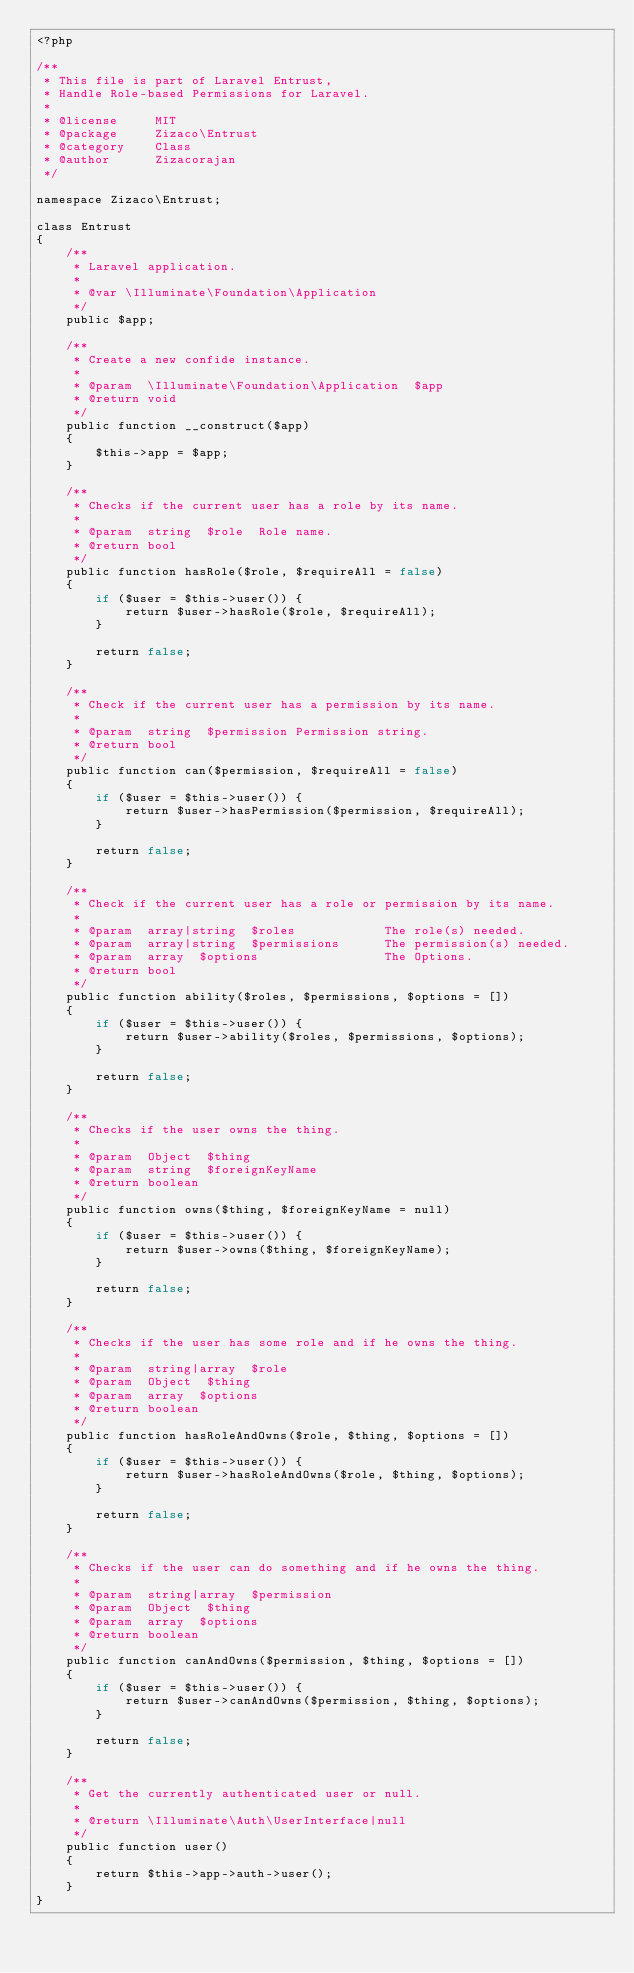<code> <loc_0><loc_0><loc_500><loc_500><_PHP_><?php

/**
 * This file is part of Laravel Entrust,
 * Handle Role-based Permissions for Laravel.
 *
 * @license     MIT
 * @package     Zizaco\Entrust
 * @category    Class
 * @author      Zizacorajan
 */

namespace Zizaco\Entrust;

class Entrust
{
    /**
     * Laravel application.
     *
     * @var \Illuminate\Foundation\Application
     */
    public $app;

    /**
     * Create a new confide instance.
     *
     * @param  \Illuminate\Foundation\Application  $app
     * @return void
     */
    public function __construct($app)
    {
        $this->app = $app;
    }

    /**
     * Checks if the current user has a role by its name.
     *
     * @param  string  $role  Role name.
     * @return bool
     */
    public function hasRole($role, $requireAll = false)
    {
        if ($user = $this->user()) {
            return $user->hasRole($role, $requireAll);
        }

        return false;
    }

    /**
     * Check if the current user has a permission by its name.
     *
     * @param  string  $permission Permission string.
     * @return bool
     */
    public function can($permission, $requireAll = false)
    {
        if ($user = $this->user()) {
            return $user->hasPermission($permission, $requireAll);
        }

        return false;
    }

    /**
     * Check if the current user has a role or permission by its name.
     *
     * @param  array|string  $roles            The role(s) needed.
     * @param  array|string  $permissions      The permission(s) needed.
     * @param  array  $options                 The Options.
     * @return bool
     */
    public function ability($roles, $permissions, $options = [])
    {
        if ($user = $this->user()) {
            return $user->ability($roles, $permissions, $options);
        }

        return false;
    }

    /**
     * Checks if the user owns the thing.
     *
     * @param  Object  $thing
     * @param  string  $foreignKeyName
     * @return boolean
     */
    public function owns($thing, $foreignKeyName = null)
    {
        if ($user = $this->user()) {
            return $user->owns($thing, $foreignKeyName);
        }

        return false;
    }

    /**
     * Checks if the user has some role and if he owns the thing.
     *
     * @param  string|array  $role
     * @param  Object  $thing
     * @param  array  $options
     * @return boolean
     */
    public function hasRoleAndOwns($role, $thing, $options = [])
    {
        if ($user = $this->user()) {
            return $user->hasRoleAndOwns($role, $thing, $options);
        }

        return false;
    }

    /**
     * Checks if the user can do something and if he owns the thing.
     *
     * @param  string|array  $permission
     * @param  Object  $thing
     * @param  array  $options
     * @return boolean
     */
    public function canAndOwns($permission, $thing, $options = [])
    {
        if ($user = $this->user()) {
            return $user->canAndOwns($permission, $thing, $options);
        }

        return false;
    }

    /**
     * Get the currently authenticated user or null.
     *
     * @return \Illuminate\Auth\UserInterface|null
     */
    public function user()
    {
        return $this->app->auth->user();
    }
}
</code> 